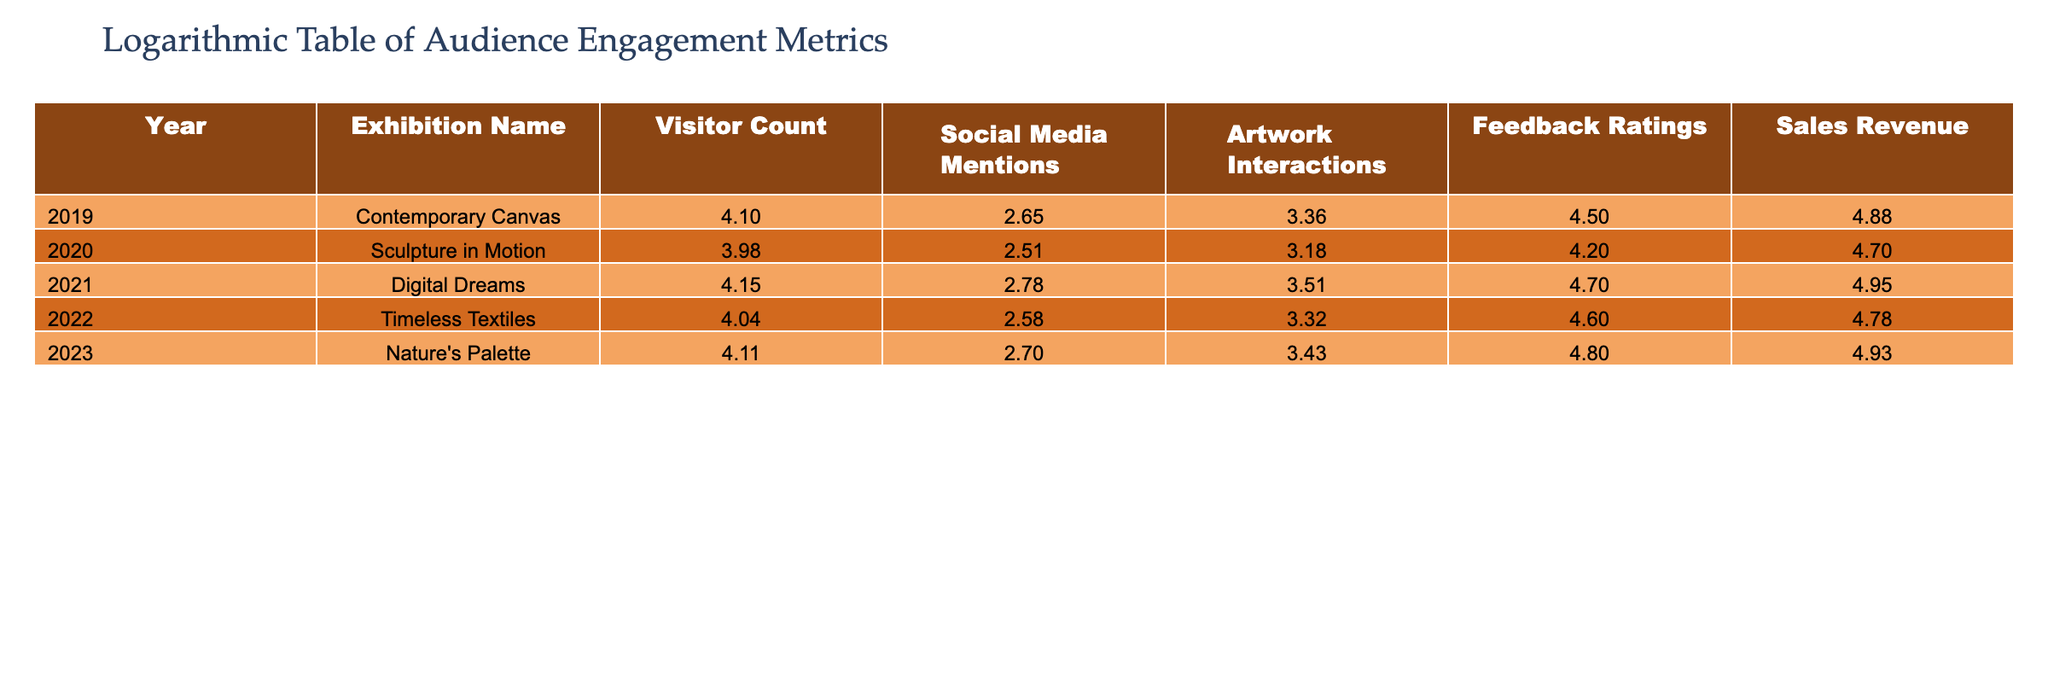What was the visitor count for the exhibition "Digital Dreams"? The table shows that the visitor count for "Digital Dreams" in 2021 was 14000.
Answer: 14000 Which exhibition had the highest social media mentions? By comparing the Social Media Mentions column, "Digital Dreams" had the highest count of 600 in 2021.
Answer: Digital Dreams What was the total sales revenue of all the exhibitions combined? To find the total sales revenue, sum the values: 75000 + 50000 + 90000 + 60000 + 85000 = 375000.
Answer: 375000 Is the feedback rating for "Nature's Palette" higher than that of "Sculpture in Motion"? The feedback rating for "Nature's Palette" is 4.8, while for "Sculpture in Motion", it is 4.2. Since 4.8 is greater than 4.2, the statement is true.
Answer: Yes What is the average artwork interactions across all exhibitions? To find the average, sum the interactions: 2300 + 1500 + 3200 + 2100 + 2700 = 11800. Then divide by 5: 11800 / 5 = 2360.
Answer: 2360 Which year saw the greatest increase in visitor count compared to the previous year? The year-on-year visitor count differences are as follows: 2019 to 2020 = -3000, 2020 to 2021 = +4500, 2021 to 2022 = -3000, 2022 to 2023 = +2000. The highest increase was from 2020 to 2021, with an increase of 4500.
Answer: 2021 Is the visitor count for "Timeless Textiles" less than the average visitor count for all exhibitions over these five years? The average visitor count is (12500 + 9500 + 14000 + 11000 + 13000) / 5 = 11600. The visitor count for "Timeless Textiles" is 11000, which is less. Thus, the answer is yes.
Answer: Yes What is the median feedback rating for the exhibitions? The feedback ratings are: 4.5, 4.2, 4.7, 4.6, 4.8. Arranging them gives: 4.2, 4.5, 4.6, 4.7, 4.8. The middle value (3rd one) is 4.6, which is the median.
Answer: 4.6 